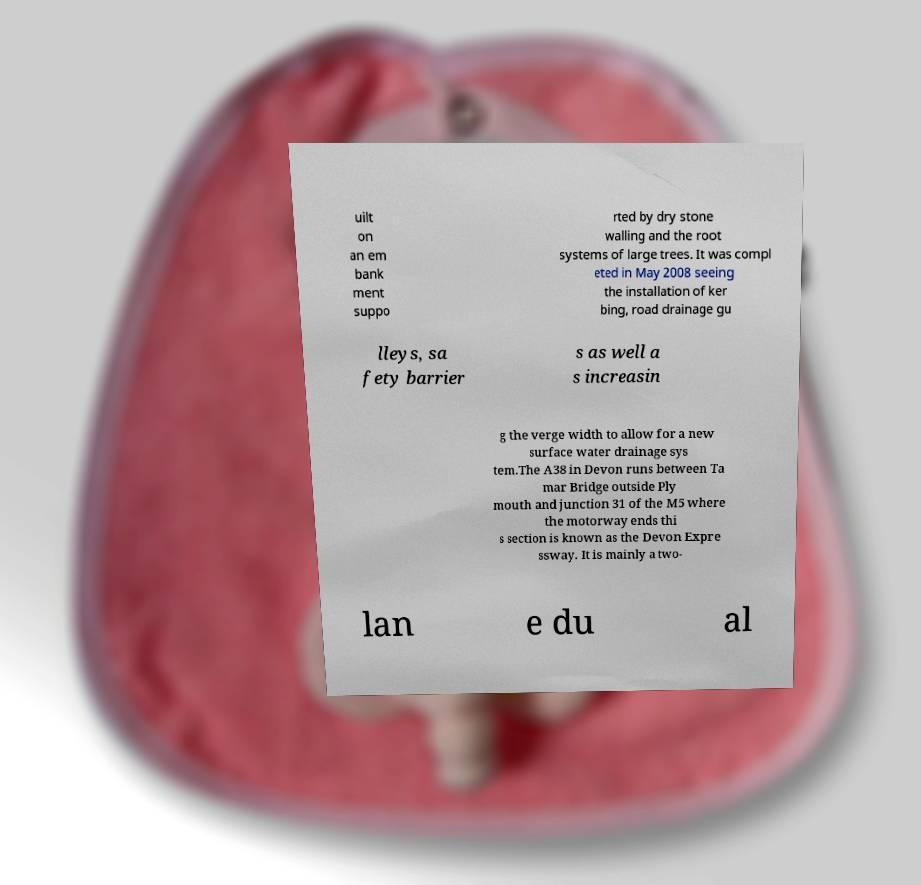There's text embedded in this image that I need extracted. Can you transcribe it verbatim? uilt on an em bank ment suppo rted by dry stone walling and the root systems of large trees. It was compl eted in May 2008 seeing the installation of ker bing, road drainage gu lleys, sa fety barrier s as well a s increasin g the verge width to allow for a new surface water drainage sys tem.The A38 in Devon runs between Ta mar Bridge outside Ply mouth and junction 31 of the M5 where the motorway ends thi s section is known as the Devon Expre ssway. It is mainly a two- lan e du al 